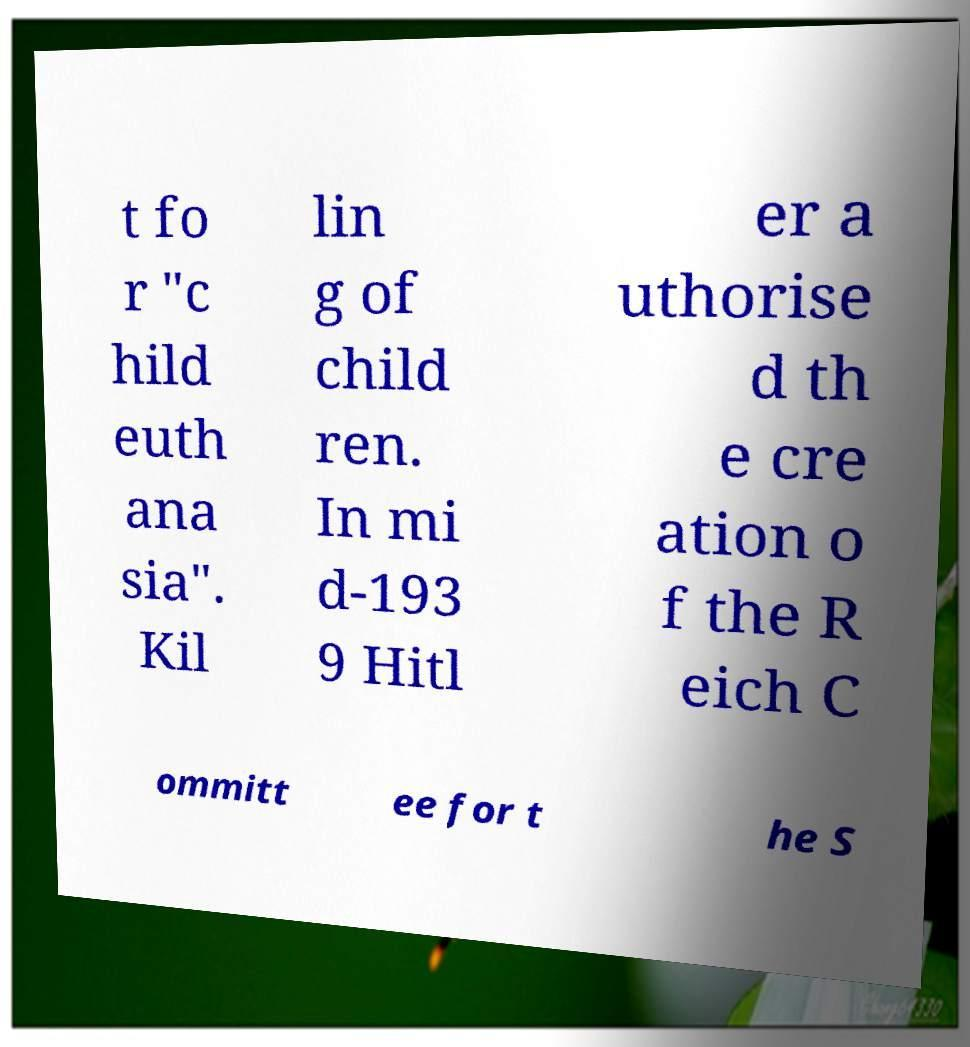For documentation purposes, I need the text within this image transcribed. Could you provide that? t fo r "c hild euth ana sia". Kil lin g of child ren. In mi d-193 9 Hitl er a uthorise d th e cre ation o f the R eich C ommitt ee for t he S 